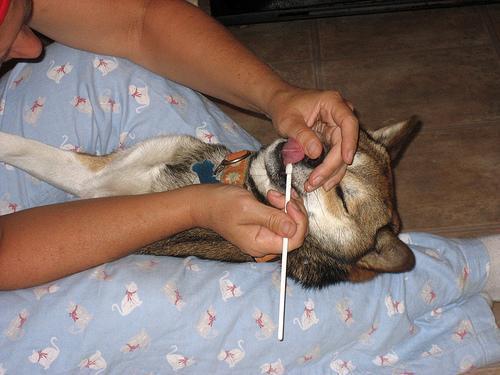How many hands are holding a giant q-tip?
Give a very brief answer. 1. 